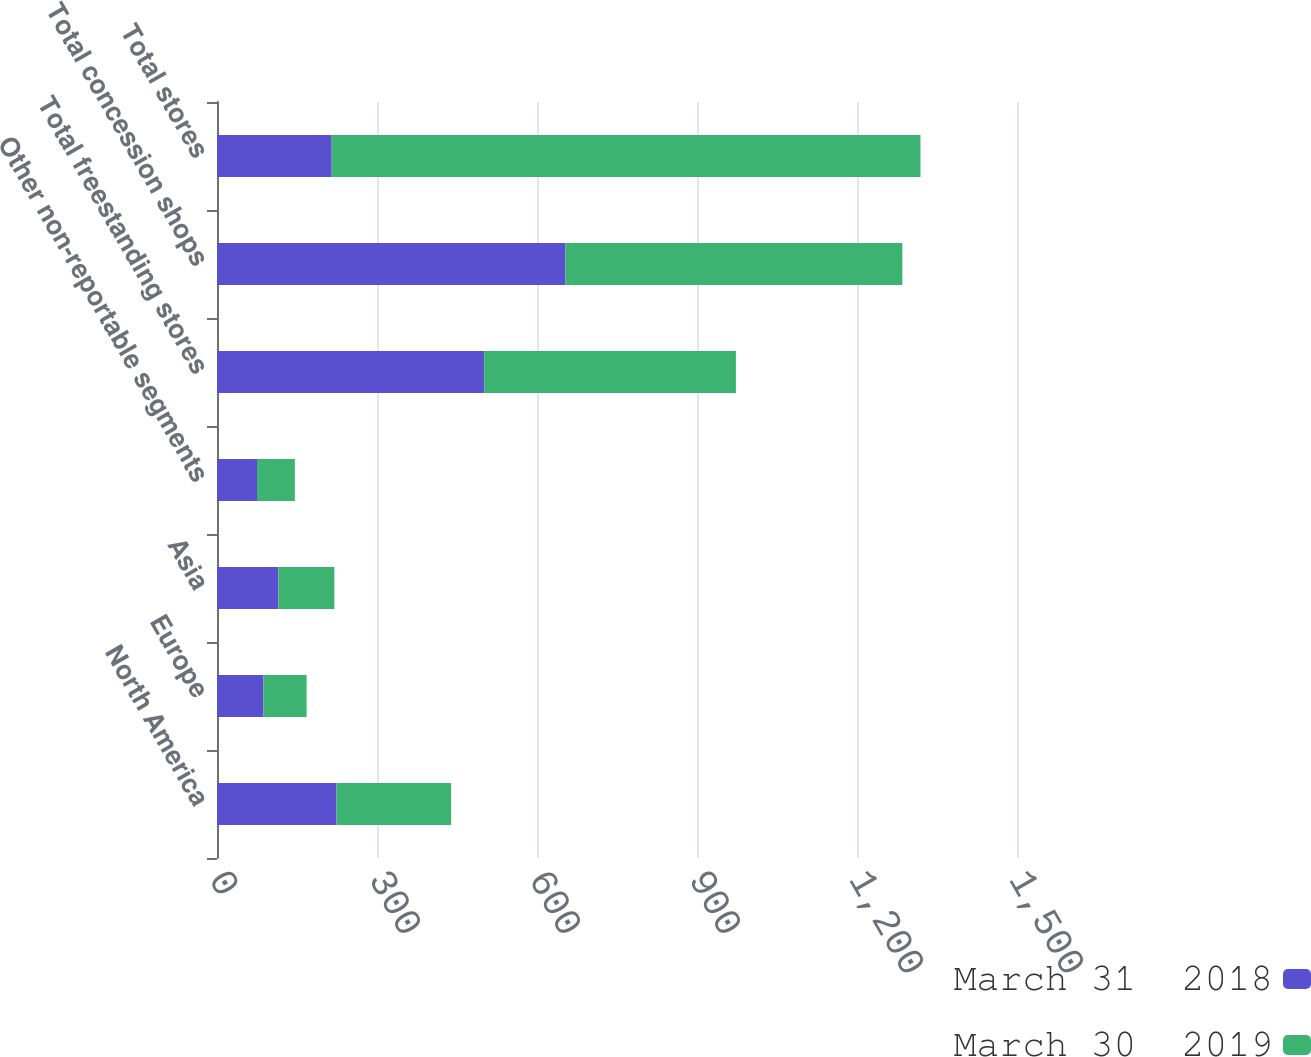Convert chart to OTSL. <chart><loc_0><loc_0><loc_500><loc_500><stacked_bar_chart><ecel><fcel>North America<fcel>Europe<fcel>Asia<fcel>Other non-reportable segments<fcel>Total freestanding stores<fcel>Total concession shops<fcel>Total stores<nl><fcel>March 31  2018<fcel>224<fcel>87<fcel>115<fcel>75<fcel>501<fcel>653<fcel>215<nl><fcel>March 30  2019<fcel>215<fcel>81<fcel>105<fcel>71<fcel>472<fcel>632<fcel>1104<nl></chart> 